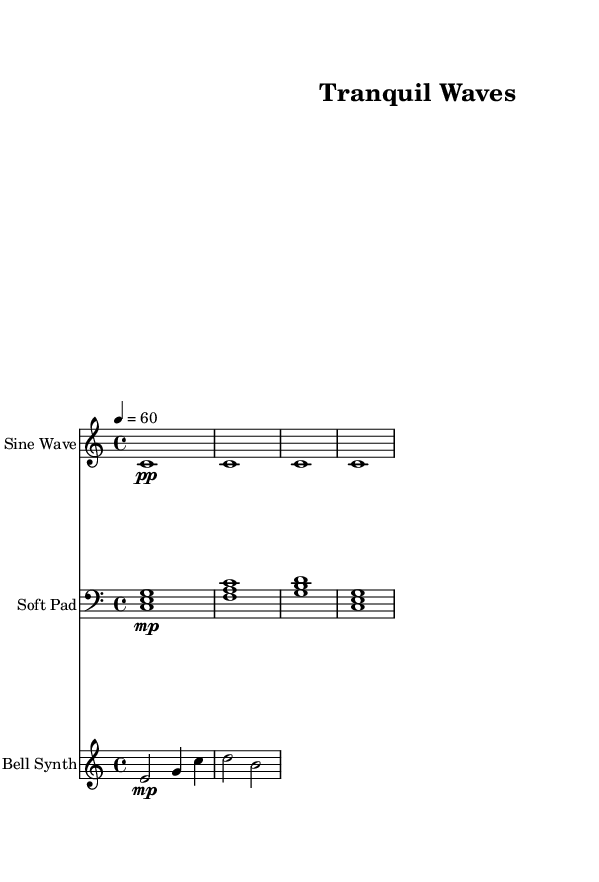What is the key signature of this music? The key signature is indicated in the score by the presence of no sharps or flats, which indicates it is in C major.
Answer: C major What is the time signature of this music? The time signature is shown at the beginning of the score and is represented as "4/4," indicating four beats per measure.
Answer: 4/4 What is the tempo marking of this sheet music? The tempo marking is located at the beginning of the score and is indicated as "4 = 60," meaning the quarter note beats at 60 beats per minute.
Answer: 60 How many different synth parts are included in this composition? The score features three different synth parts: Sine Wave, Soft Pad, and Bell Synth, which are displayed in separate staves.
Answer: Three Which instrument has the quietest dynamic marking? The Sine Wave part has the dynamic marking of "pp," suggesting a very quiet sound compared to the other parts, which have "mp" for the Soft Pad and Bell Synth.
Answer: Sine Wave Which type of synth plays the chord progression? The Soft Pad part plays the chord progression, evidenced by the presence of stacked notes that indicate harmony, specifically the notes C, E, G; F, A, C; G, B, D; and C, E, G.
Answer: Soft Pad What is the rhythmic pattern of the Bell Synth part? The Bell Synth part features a combination of half notes and quarter notes, leading to a more varied rhythmic texture, with two half notes and a pair of quarter notes in its only measure.
Answer: Half notes and quarter notes 